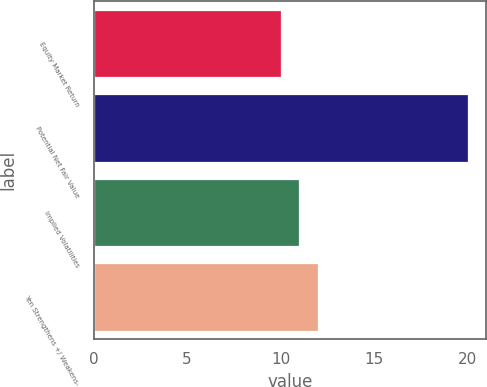<chart> <loc_0><loc_0><loc_500><loc_500><bar_chart><fcel>Equity Market Return<fcel>Potential Net Fair Value<fcel>Implied Volatilities<fcel>Yen Strengthens +/ Weakens-<nl><fcel>10<fcel>20<fcel>11<fcel>12<nl></chart> 